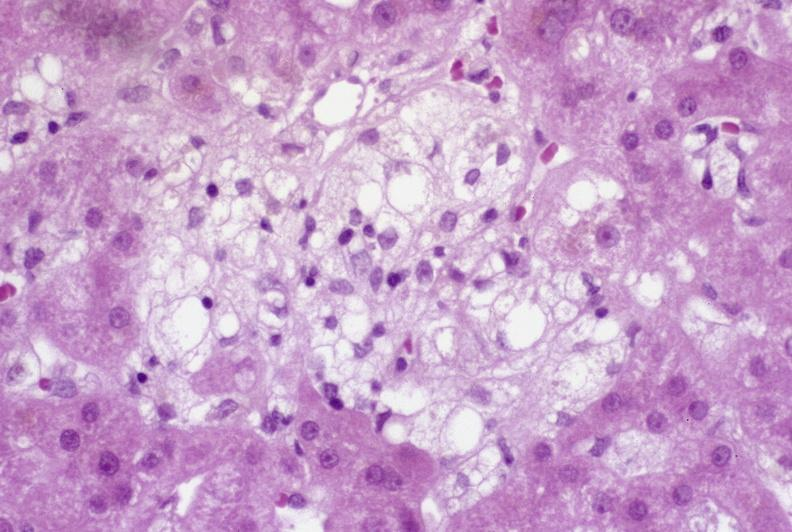s situs inversus present?
Answer the question using a single word or phrase. No 